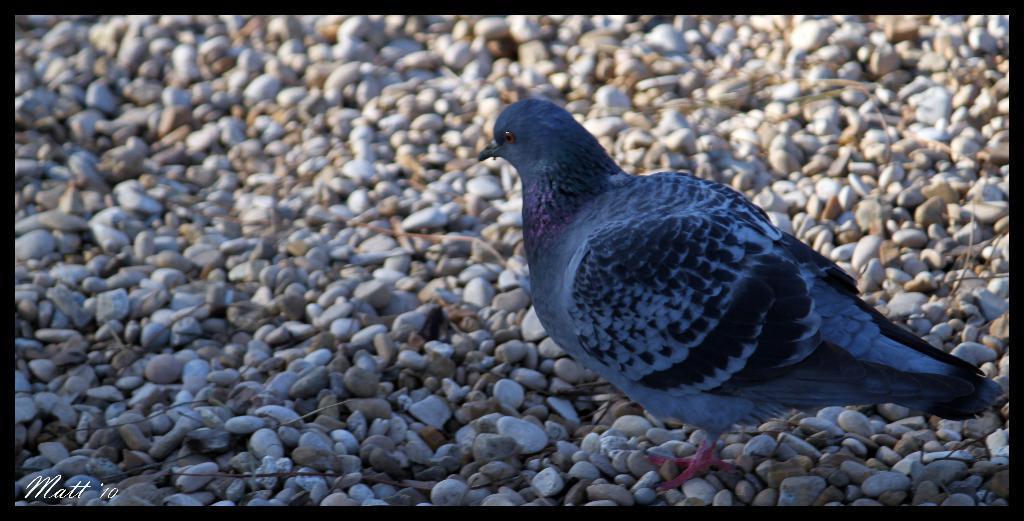Please provide a concise description of this image. In this image I can see a pigeon on the ground. Here I can see some stones and also see a watermark over here. 